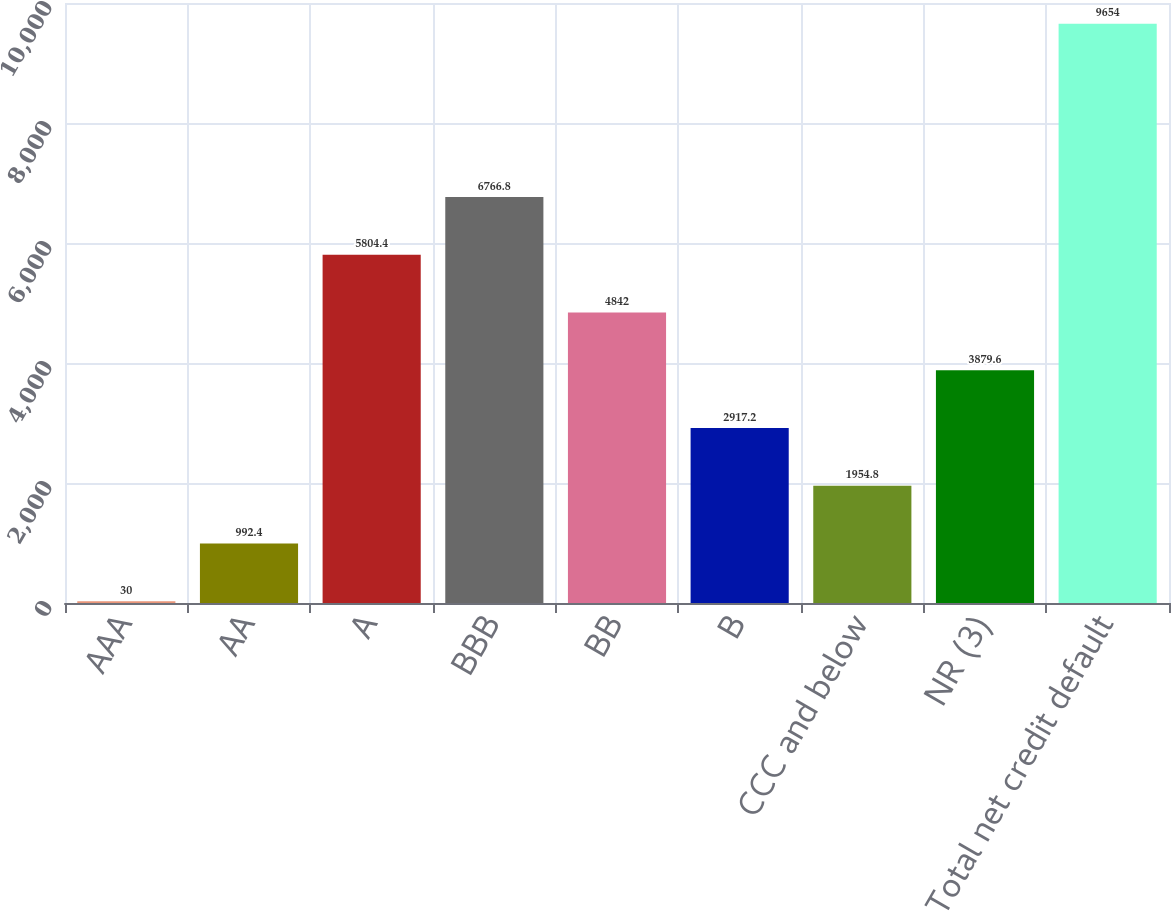Convert chart to OTSL. <chart><loc_0><loc_0><loc_500><loc_500><bar_chart><fcel>AAA<fcel>AA<fcel>A<fcel>BBB<fcel>BB<fcel>B<fcel>CCC and below<fcel>NR (3)<fcel>Total net credit default<nl><fcel>30<fcel>992.4<fcel>5804.4<fcel>6766.8<fcel>4842<fcel>2917.2<fcel>1954.8<fcel>3879.6<fcel>9654<nl></chart> 